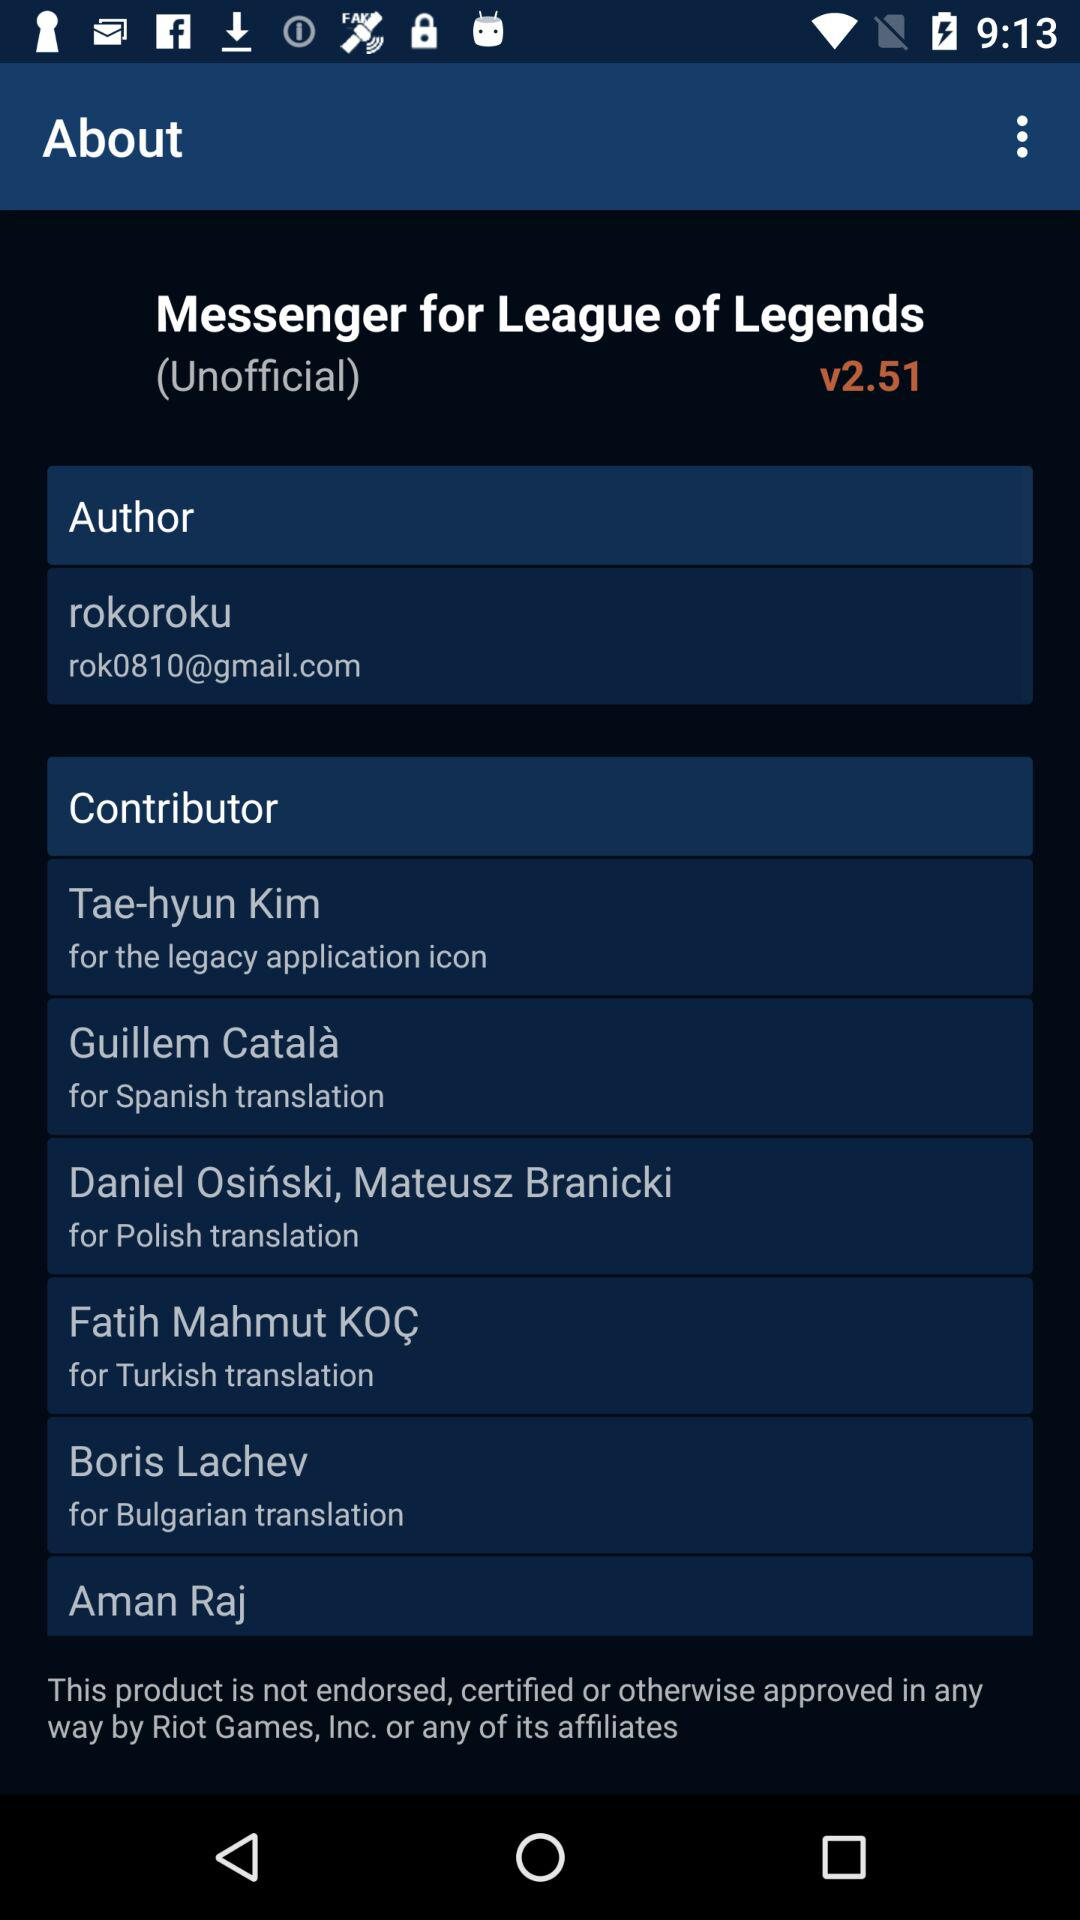Who is the contributor for the legacy application icon? The contributor is Tae-hyun Kim. 